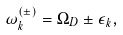<formula> <loc_0><loc_0><loc_500><loc_500>\omega _ { k } ^ { ( \pm ) } = \Omega _ { D } \pm \epsilon _ { k } ,</formula> 